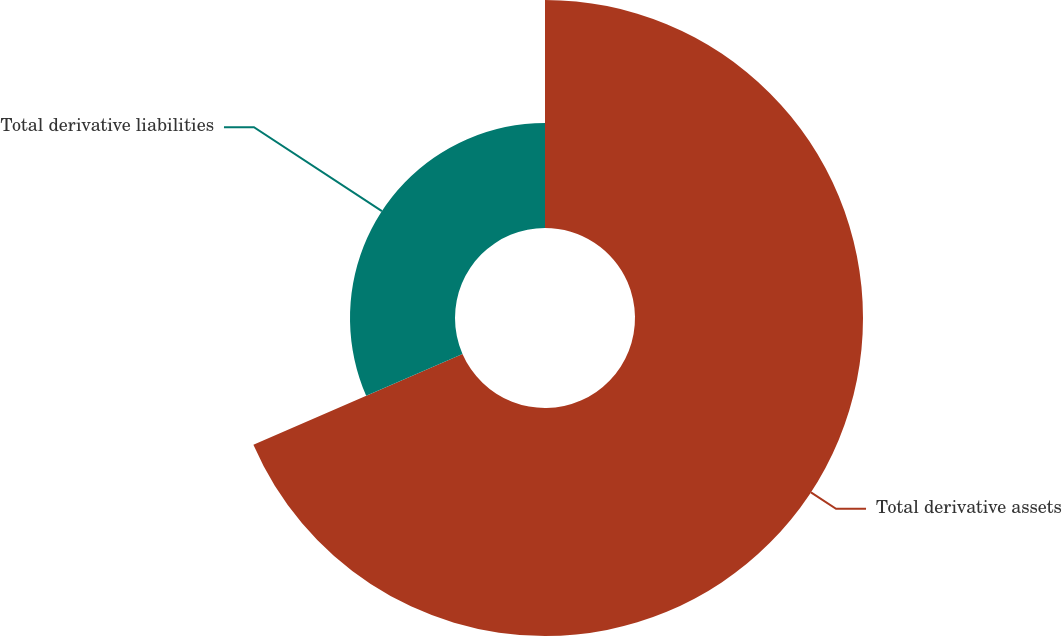Convert chart to OTSL. <chart><loc_0><loc_0><loc_500><loc_500><pie_chart><fcel>Total derivative assets<fcel>Total derivative liabilities<nl><fcel>68.47%<fcel>31.53%<nl></chart> 